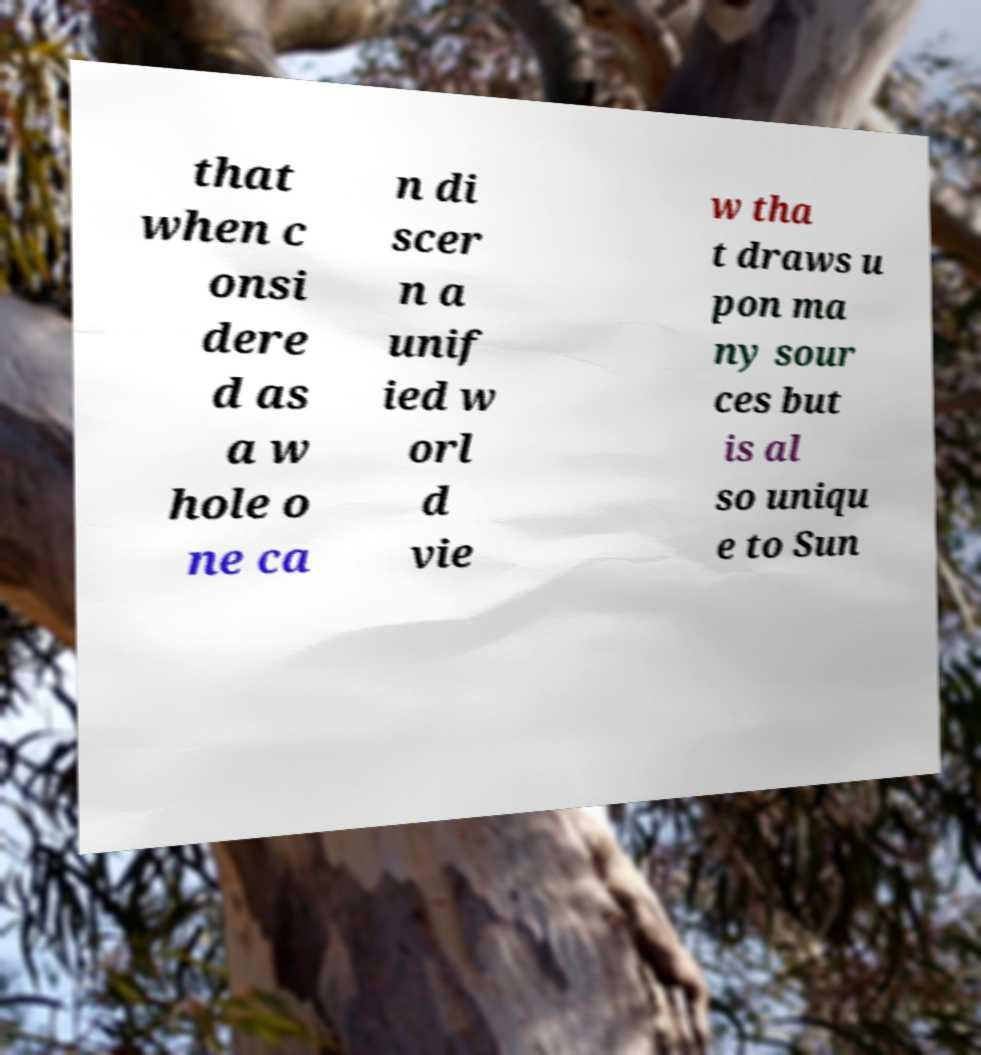What messages or text are displayed in this image? I need them in a readable, typed format. that when c onsi dere d as a w hole o ne ca n di scer n a unif ied w orl d vie w tha t draws u pon ma ny sour ces but is al so uniqu e to Sun 